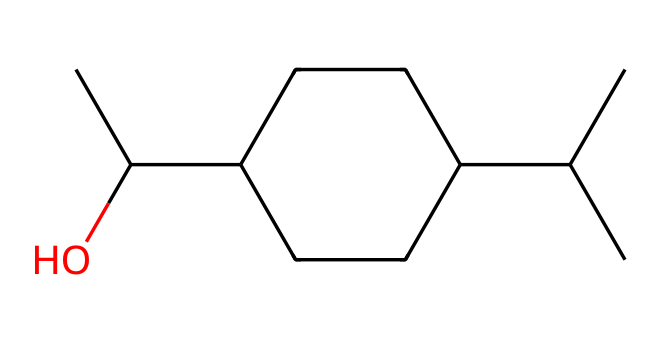What is the molecular formula of this compound? By counting the number of each type of atom represented in the SMILES string, I observe 12 carbon (C) atoms, 22 hydrogen (H) atoms, and 1 oxygen (O) atom. Therefore, the molecular formula can be derived from the counts of each atom.
Answer: C12H22O How many rings are present in the structure? Examining the structure, there is one cyclohexane ring which is confirmed by the presence of the notation "C1" and "CC1". This indicates that there is a cyclic component in the molecular structure.
Answer: 1 What type of hypervalent compound class does this belong to? Evaluating the structure, this compound contains carbon and is a type of cycloalkane due to the presence of cyclohexane rings while also being called a terpenoid due to its molecular features. Hypervalent compounds often involve elements that can expand their valence shells, but in this case, it fits more closely into a class of saturated cyclic compounds.
Answer: cycloalkane Does this compound have any functional groups? Looking at the structure, there appears to be a hydroxyl group (-OH) attached to one of the carbon atoms, indicating the presence of an alcohol functional group in the molecule.
Answer: alcohol What is the degree of saturation of this compound? The degree of saturation can be determined by analyzing the number of rings and multiple bonds in the compound. Since there is one cyclohexane ring and no double or triple bonds, the compound is fully saturated.
Answer: fully saturated 